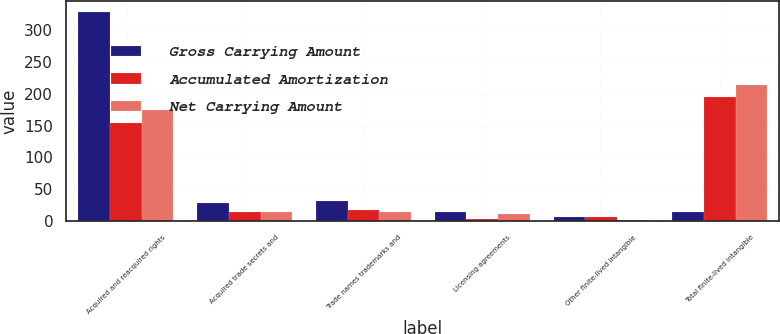Convert chart to OTSL. <chart><loc_0><loc_0><loc_500><loc_500><stacked_bar_chart><ecel><fcel>Acquired and reacquired rights<fcel>Acquired trade secrets and<fcel>Trade names trademarks and<fcel>Licensing agreements<fcel>Other finite-lived intangible<fcel>Total finite-lived intangible<nl><fcel>Gross Carrying Amount<fcel>328.8<fcel>27.6<fcel>31.5<fcel>14.4<fcel>6.7<fcel>14.4<nl><fcel>Accumulated Amortization<fcel>154.2<fcel>13.7<fcel>17.6<fcel>3.8<fcel>5.5<fcel>194.8<nl><fcel>Net Carrying Amount<fcel>174.6<fcel>13.9<fcel>13.9<fcel>10.6<fcel>1.2<fcel>214.2<nl></chart> 